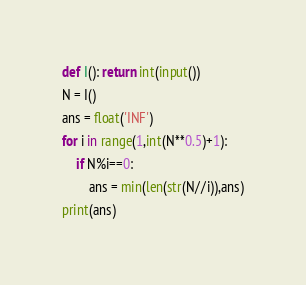Convert code to text. <code><loc_0><loc_0><loc_500><loc_500><_Python_>def I(): return int(input())
N = I()
ans = float('INF')
for i in range(1,int(N**0.5)+1):
    if N%i==0:
        ans = min(len(str(N//i)),ans)
print(ans)
</code> 